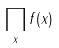<formula> <loc_0><loc_0><loc_500><loc_500>\prod _ { x } f ( x )</formula> 